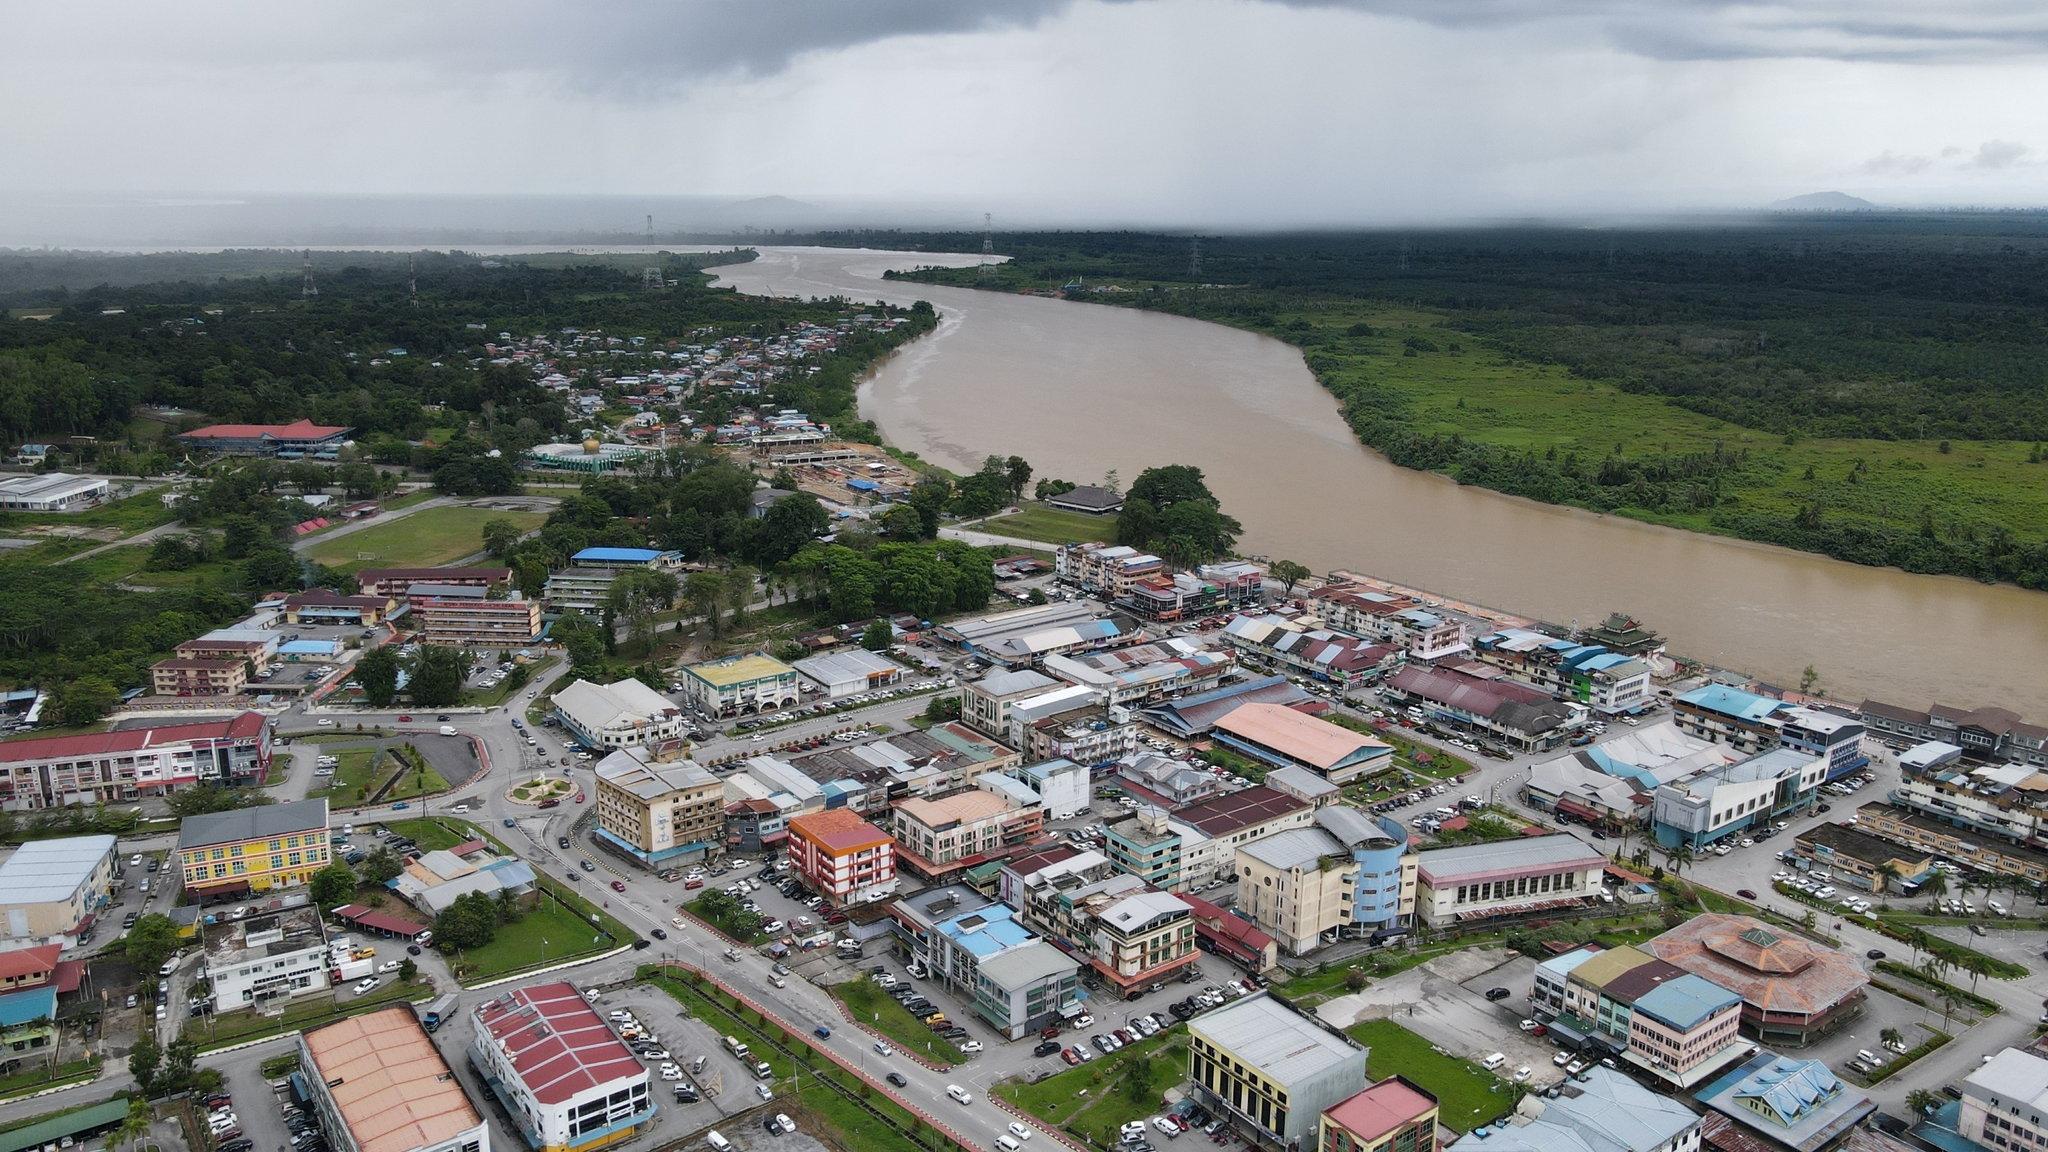Can you describe a day in the life of this town? A day in this town likely begins with the rising sun casting its first light over the river, illuminating the colorful rooftops and bustling streets. Early morning activities might include locals heading to markets to purchase fresh produce, children walking to school, and shopkeepers preparing for the day's business. As the day progresses, the streets become increasingly busy with people going about their daily routines—drivers navigating the roads, pedestrians browsing shops, and families enjoying the town's public spaces. By afternoon, the town is a hive of activity, with social interactions and commerce thriving. As evening approaches, the streets might quiet down as people return home, and the town's lights create a warm, welcoming glow. Nightfall brings a serene atmosphere with the gentle sound of the river flowing and the town resting under the overcast sky, preparing for another day. 